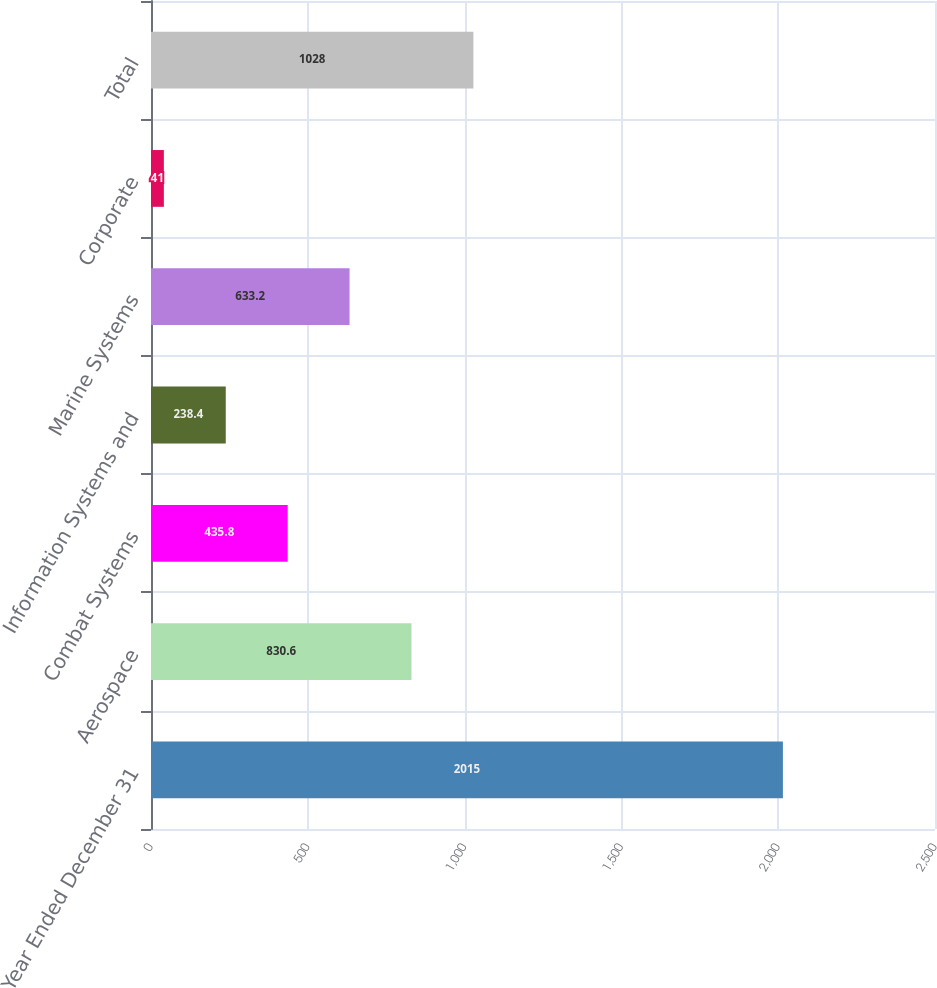Convert chart to OTSL. <chart><loc_0><loc_0><loc_500><loc_500><bar_chart><fcel>Year Ended December 31<fcel>Aerospace<fcel>Combat Systems<fcel>Information Systems and<fcel>Marine Systems<fcel>Corporate<fcel>Total<nl><fcel>2015<fcel>830.6<fcel>435.8<fcel>238.4<fcel>633.2<fcel>41<fcel>1028<nl></chart> 